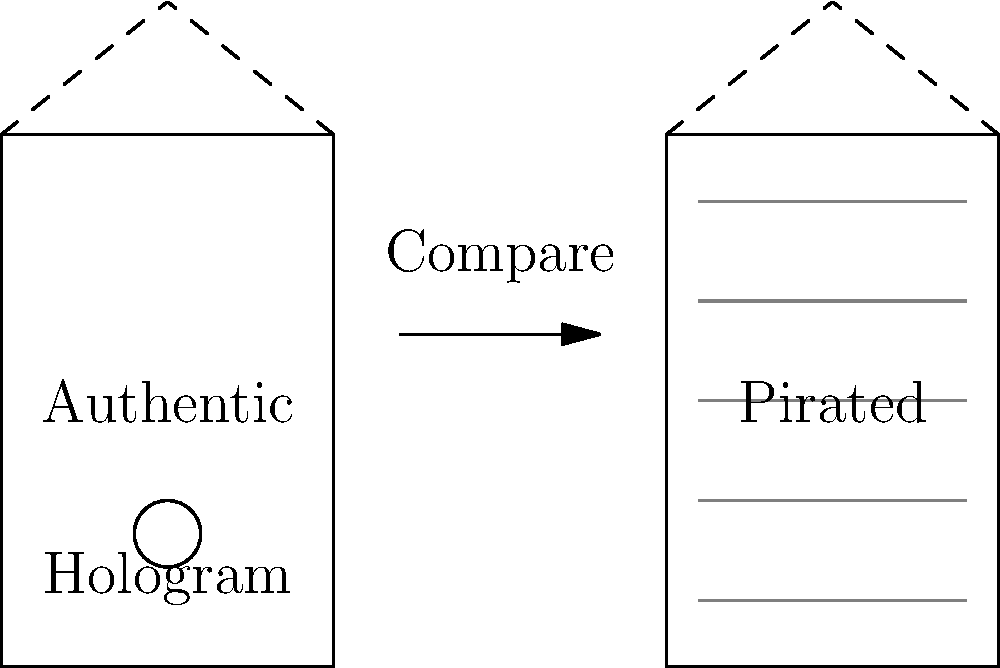As a law enforcement officer investigating software piracy, you come across two software packages. The authentic package has a holographic security feature, while the pirated version shows signs of low-quality printing. What is the primary visual difference that helps you distinguish between the authentic and pirated software packaging? To identify the primary visual difference between authentic and pirated software packaging, follow these steps:

1. Examine the authentic package:
   - Notice the presence of a circular hologram on the left side of the box.
   - Observe the clean, crisp appearance of the packaging.

2. Examine the pirated package:
   - Notice the absence of any security features like holograms.
   - Observe the presence of horizontal gray lines, indicating low-quality printing.

3. Compare the two packages:
   - The authentic package has a distinct security feature (hologram) that the pirated version lacks.
   - The pirated version shows signs of inferior print quality, which is not present in the authentic package.

4. Identify the key distinguishing factor:
   - While both the hologram and print quality are differences, the hologram is a more definitive and easily identifiable security feature.
   - The presence or absence of the hologram provides a quick and reliable way to distinguish between authentic and pirated software packaging.

Therefore, the primary visual difference that helps distinguish between the authentic and pirated software packaging is the presence of the holographic security feature on the authentic package.
Answer: Holographic security feature 